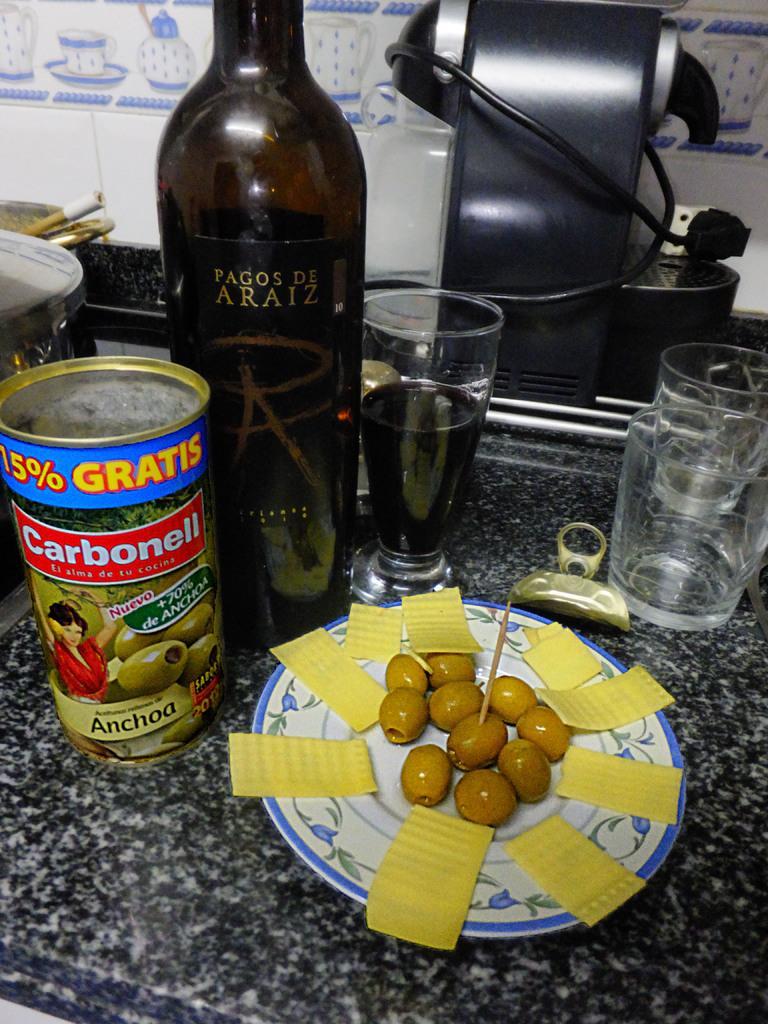How would you summarize this image in a sentence or two? We can see bottle,food,plate,glasses and objects on the surface. In the background we can see wall. 